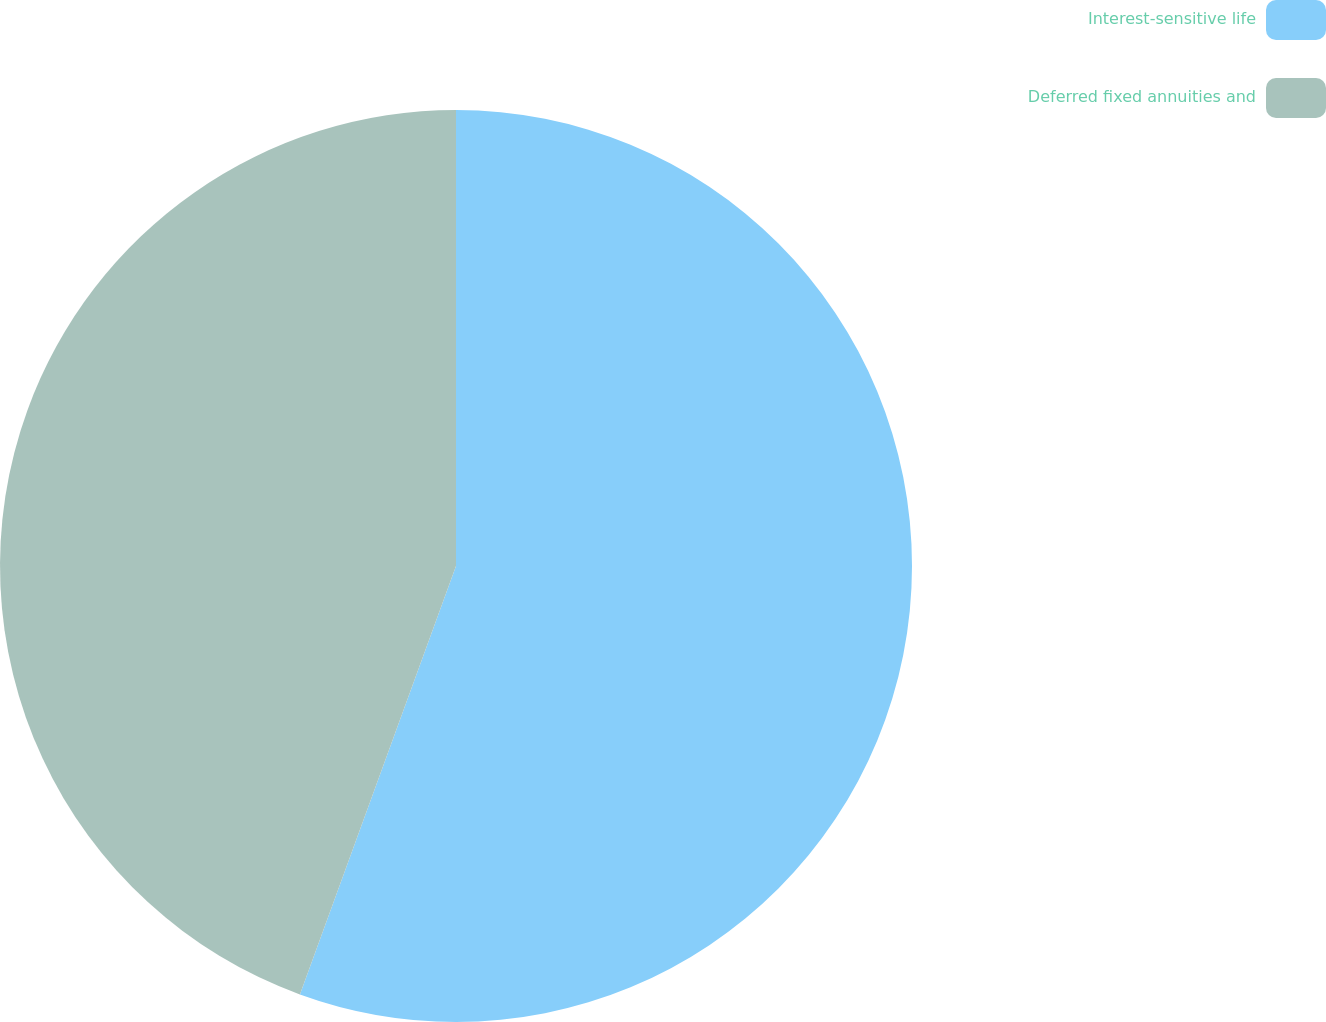<chart> <loc_0><loc_0><loc_500><loc_500><pie_chart><fcel>Interest-sensitive life<fcel>Deferred fixed annuities and<nl><fcel>55.56%<fcel>44.44%<nl></chart> 